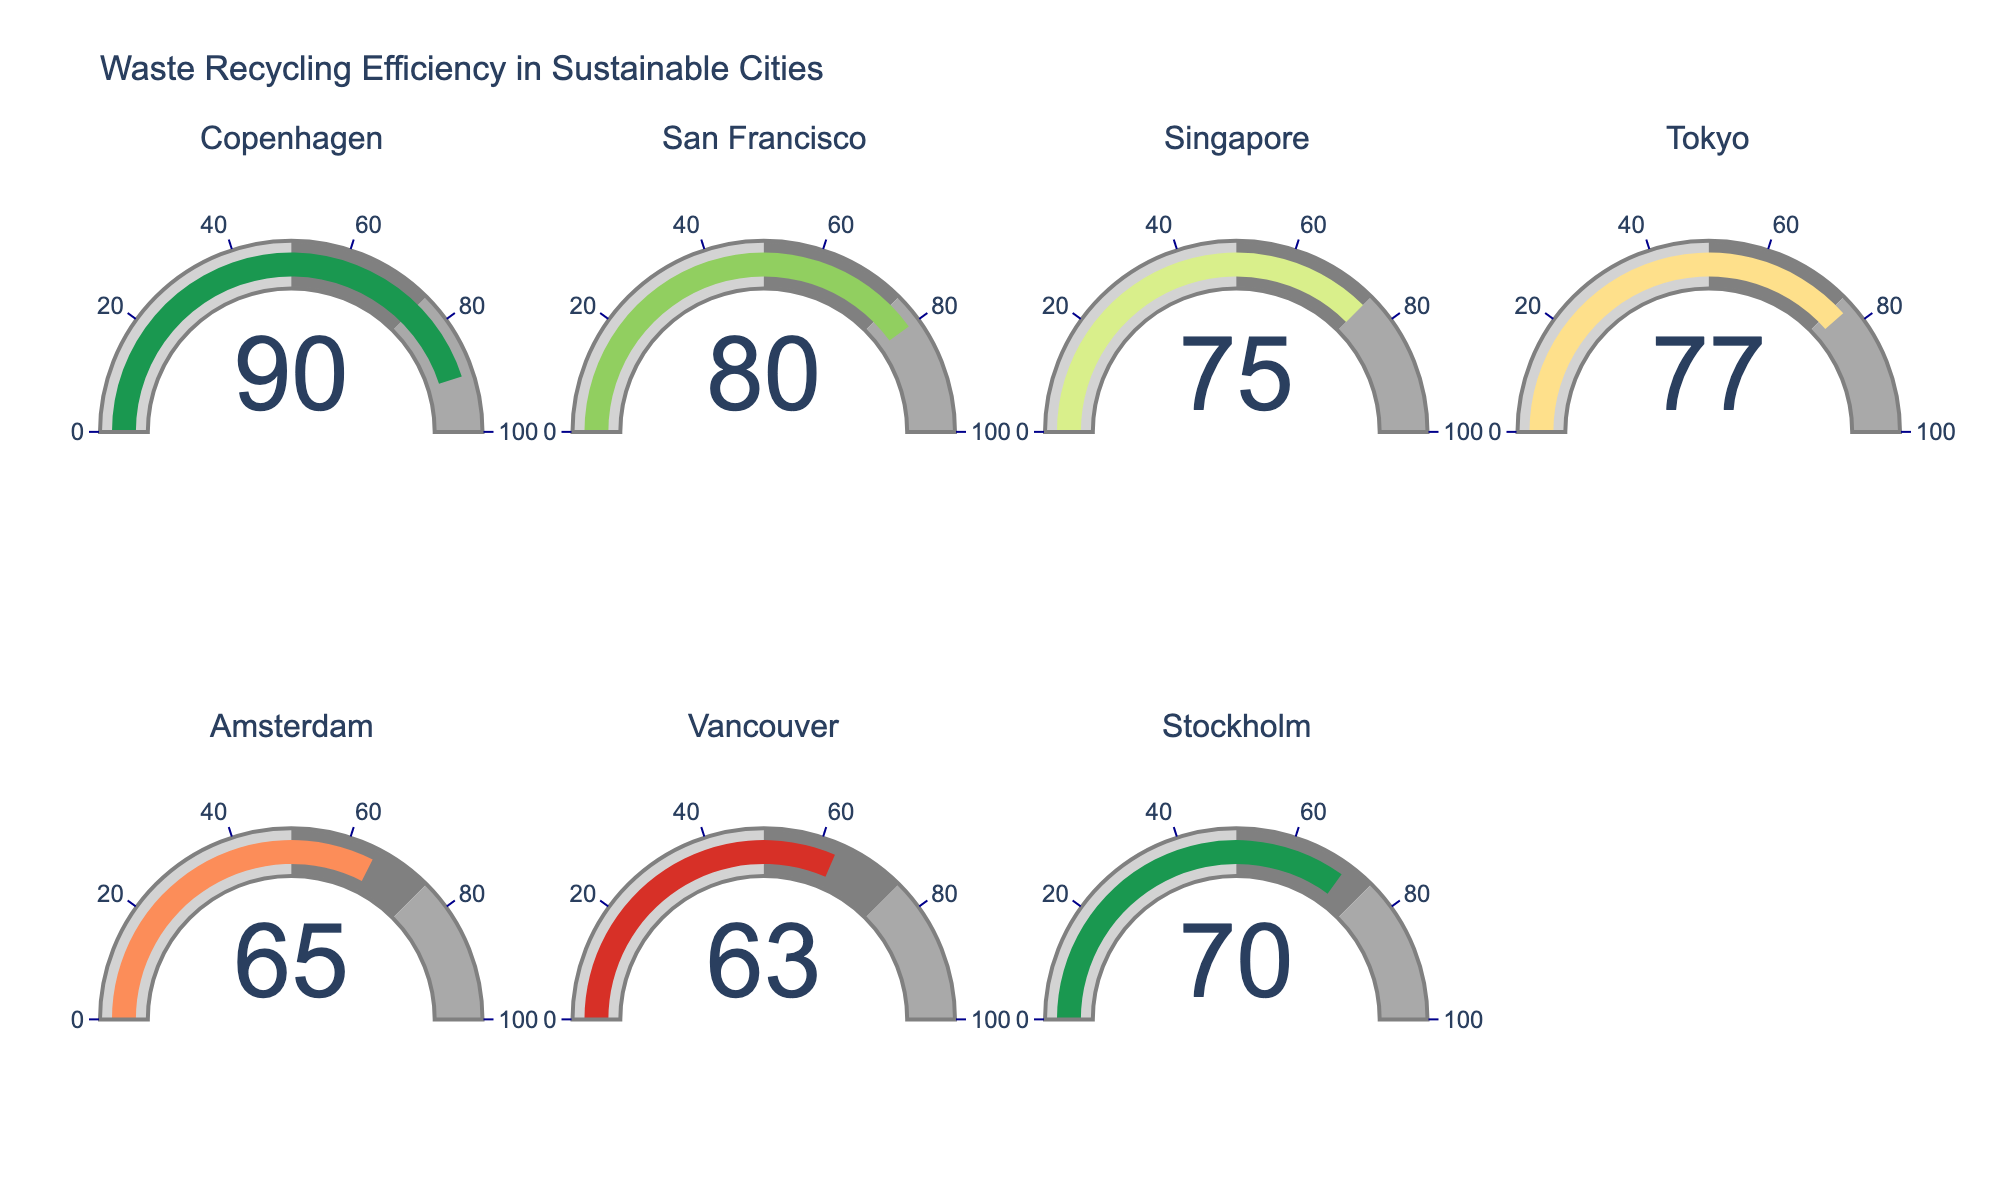Which city has the highest recycling rate? The gauge charts display the recycling rates for different cities. By comparing the values, Copenhagen has the highest recycling rate.
Answer: Copenhagen What's the average recycling rate of all the cities? The rates are: 90, 80, 75, 77, 65, 63, 70. Summing these up: 90 + 80 + 75 + 77 + 65 + 63 + 70 = 520. There are 7 cities, so the average is 520 / 7 ≈ 74.29.
Answer: 74.29 Which city has a recycling rate closest to 70%? By looking at the gauge charts, the closet rate to 70% is Vancouver with 70%.
Answer: Vancouver How many cities have a recycling rate of 75% or higher? Count the number of cities with rates equal to or greater than 75 from the gauge charts. We have: Copenhagen (90), San Francisco (80), Singapore (75), and Tokyo (77). So, 4 cities.
Answer: 4 How much higher is Copenhagen's recycling rate compared to Stockholm's? Copenhagen's rate is 90% and Stockholm's rate is 70%. The difference is 90 - 70 = 20.
Answer: 20 What percentage range is used to represent the "dark gray" area on the gauge charts? By looking at the gauge color segments, dark gray represents the range from 75% to 100%.
Answer: 75% to 100% Rank the cities from highest to lowest recycling rate. From the gauge charts, the recycling rates are: Copenhagen (90), San Francisco (80), Tokyo (77), Singapore (75), Amsterdam (65), Vancouver (63), and Stockholm (70). Ordering them gives: Copenhagen, San Francisco, Tokyo, Singapore, Stockholm, Amsterdam, Vancouver.
Answer: Copenhagen, San Francisco, Tokyo, Singapore, Stockholm, Amsterdam, Vancouver Compare the recycling rate of Amsterdam with the average rate of San Francisco and Vancouver. San Francisco's rate is 80%, and Vancouver's is 63%. Their average is (80 + 63) / 2 = 71.5. Comparing it to Amsterdam’s rate of 65%, Amsterdam’s rate is lower by (71.5 - 65) = 6.5.
Answer: 6.5 Identify the city with a recycling rate below 65%. Analyzing the gauge charts, the city with a recycling rate below 65% is Vancouver with 63%.
Answer: Vancouver 